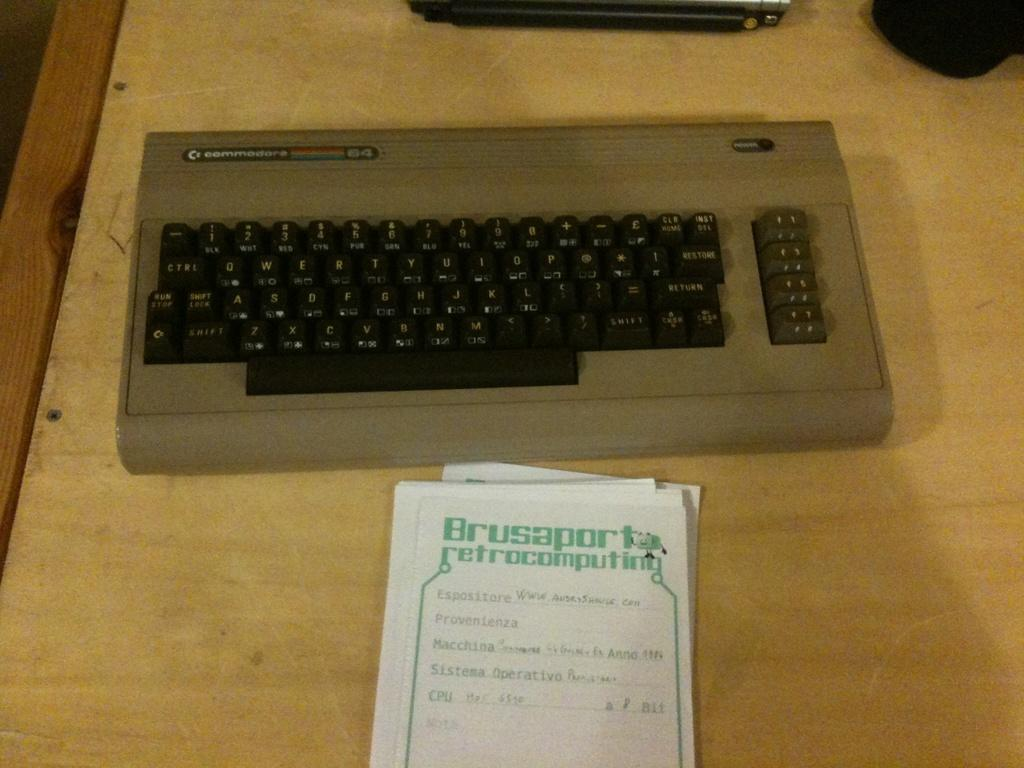<image>
Render a clear and concise summary of the photo. A keyboard on a table and a piece of paper that says "Brusaport" on the header. 